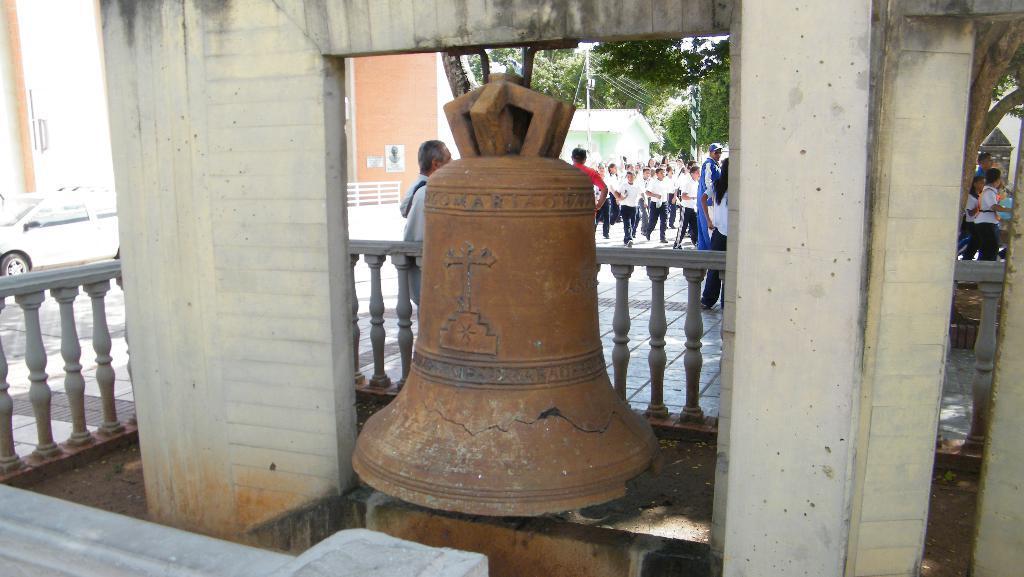In one or two sentences, can you explain what this image depicts? In this image we can see the bell, soil, wall, railing, building and also the house. We can also see the electrical pole with wires. We can see the trees, vehicle, road and also the people walking on the path. 